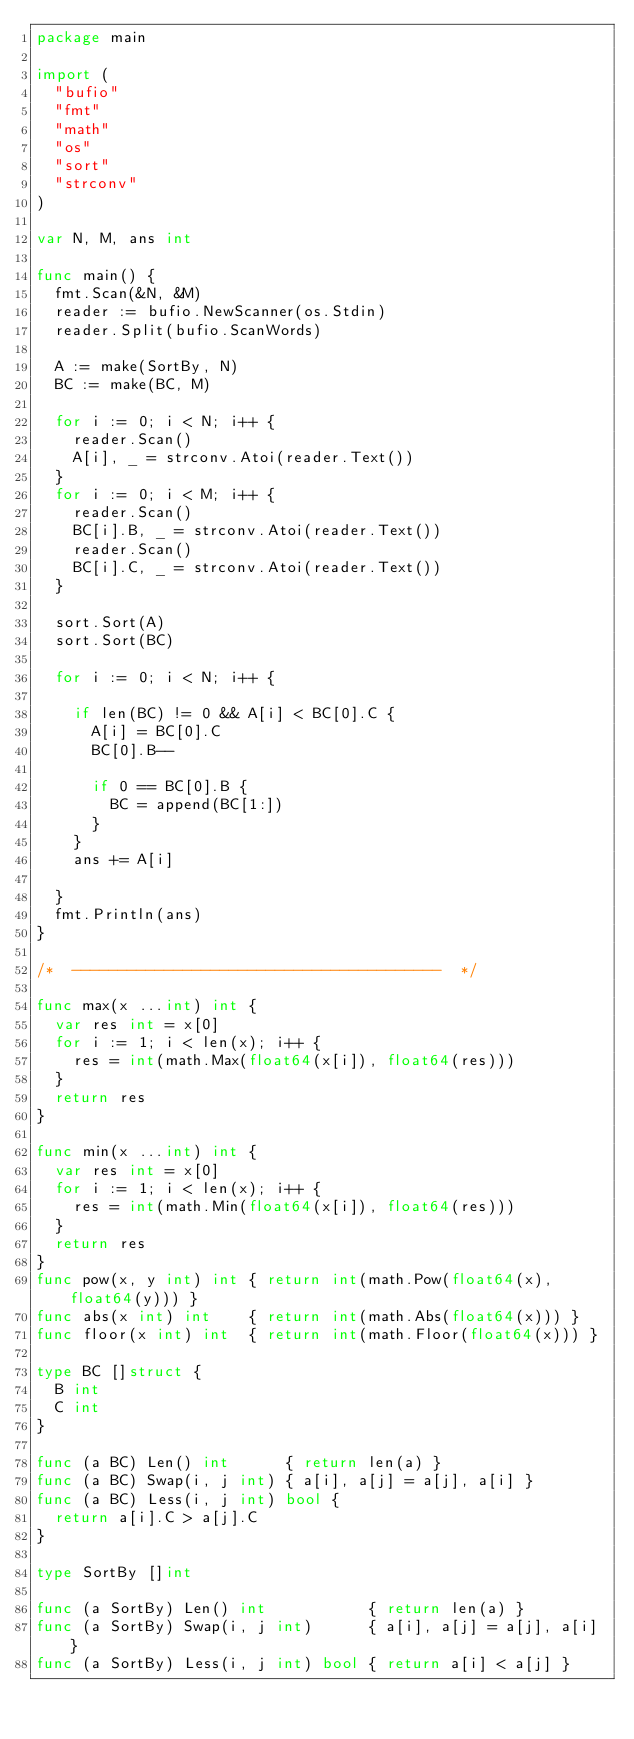<code> <loc_0><loc_0><loc_500><loc_500><_Go_>package main

import (
	"bufio"
	"fmt"
	"math"
	"os"
	"sort"
	"strconv"
)

var N, M, ans int

func main() {
	fmt.Scan(&N, &M)
	reader := bufio.NewScanner(os.Stdin)
	reader.Split(bufio.ScanWords)

	A := make(SortBy, N)
	BC := make(BC, M)

	for i := 0; i < N; i++ {
		reader.Scan()
		A[i], _ = strconv.Atoi(reader.Text())
	}
	for i := 0; i < M; i++ {
		reader.Scan()
		BC[i].B, _ = strconv.Atoi(reader.Text())
		reader.Scan()
		BC[i].C, _ = strconv.Atoi(reader.Text())
	}

	sort.Sort(A)
	sort.Sort(BC)

	for i := 0; i < N; i++ {

		if len(BC) != 0 && A[i] < BC[0].C {
			A[i] = BC[0].C
			BC[0].B--

			if 0 == BC[0].B {
				BC = append(BC[1:])
			}
		}
		ans += A[i]

	}
	fmt.Println(ans)
}

/*  ----------------------------------------  */

func max(x ...int) int {
	var res int = x[0]
	for i := 1; i < len(x); i++ {
		res = int(math.Max(float64(x[i]), float64(res)))
	}
	return res
}

func min(x ...int) int {
	var res int = x[0]
	for i := 1; i < len(x); i++ {
		res = int(math.Min(float64(x[i]), float64(res)))
	}
	return res
}
func pow(x, y int) int { return int(math.Pow(float64(x), float64(y))) }
func abs(x int) int    { return int(math.Abs(float64(x))) }
func floor(x int) int  { return int(math.Floor(float64(x))) }

type BC []struct {
	B int
	C int
}

func (a BC) Len() int      { return len(a) }
func (a BC) Swap(i, j int) { a[i], a[j] = a[j], a[i] }
func (a BC) Less(i, j int) bool {
	return a[i].C > a[j].C
}

type SortBy []int

func (a SortBy) Len() int           { return len(a) }
func (a SortBy) Swap(i, j int)      { a[i], a[j] = a[j], a[i] }
func (a SortBy) Less(i, j int) bool { return a[i] < a[j] }
</code> 